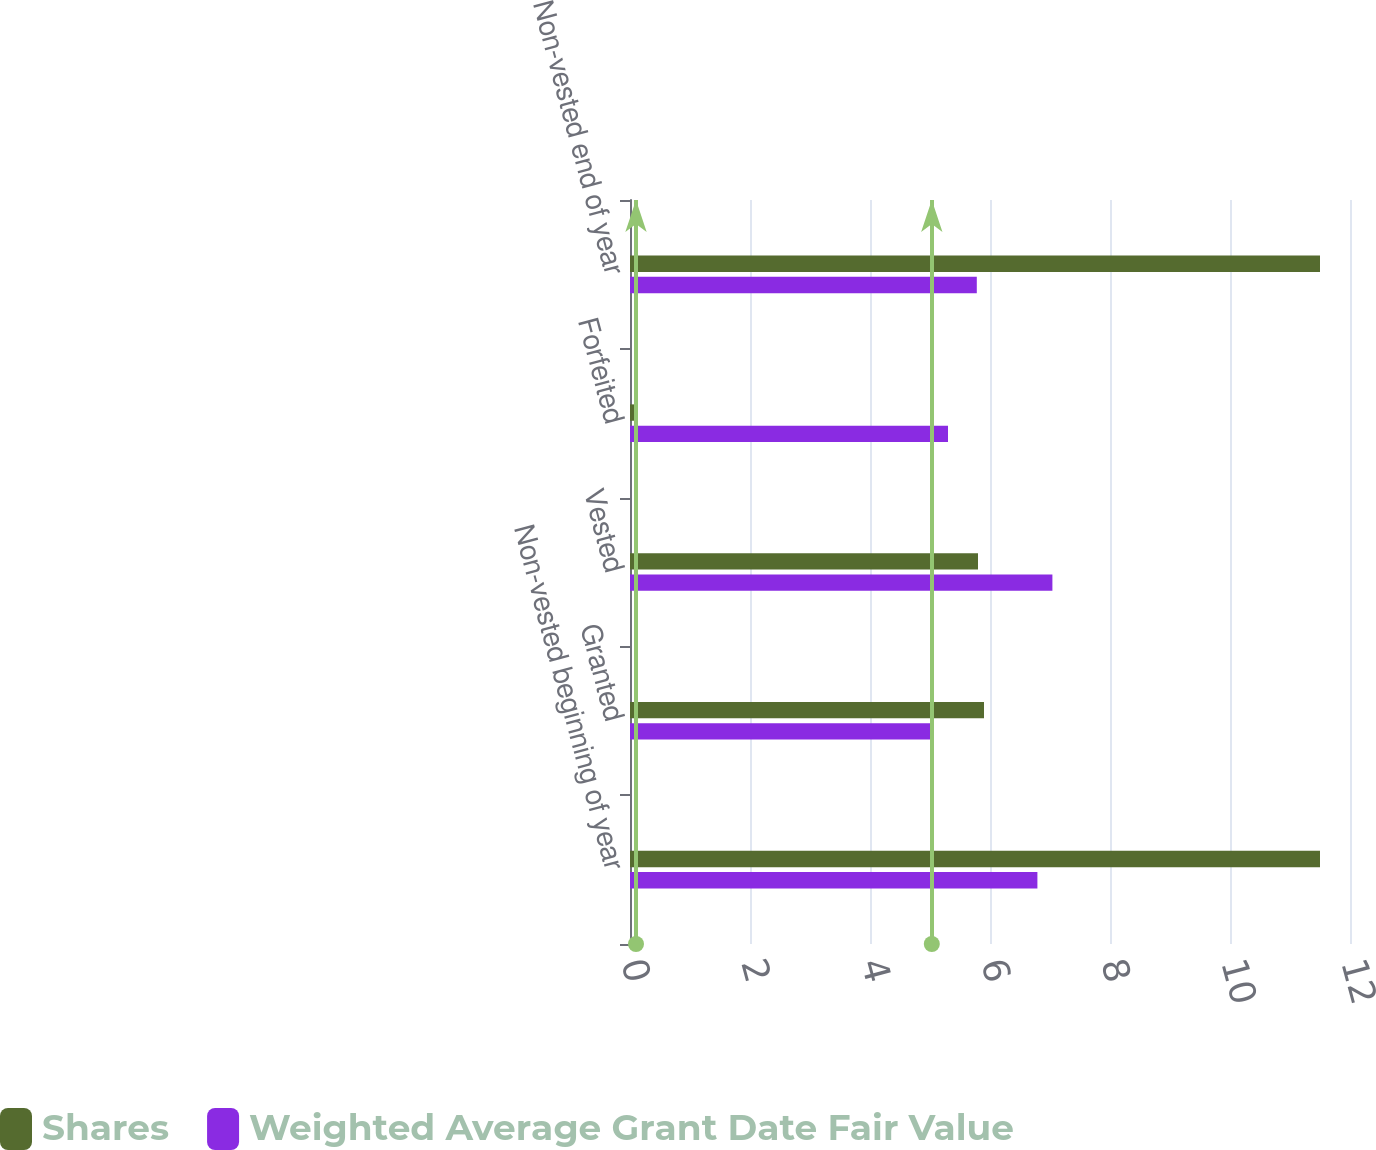<chart> <loc_0><loc_0><loc_500><loc_500><stacked_bar_chart><ecel><fcel>Non-vested beginning of year<fcel>Granted<fcel>Vested<fcel>Forfeited<fcel>Non-vested end of year<nl><fcel>Shares<fcel>11.5<fcel>5.9<fcel>5.8<fcel>0.1<fcel>11.5<nl><fcel>Weighted Average Grant Date Fair Value<fcel>6.79<fcel>5.03<fcel>7.04<fcel>5.3<fcel>5.78<nl></chart> 